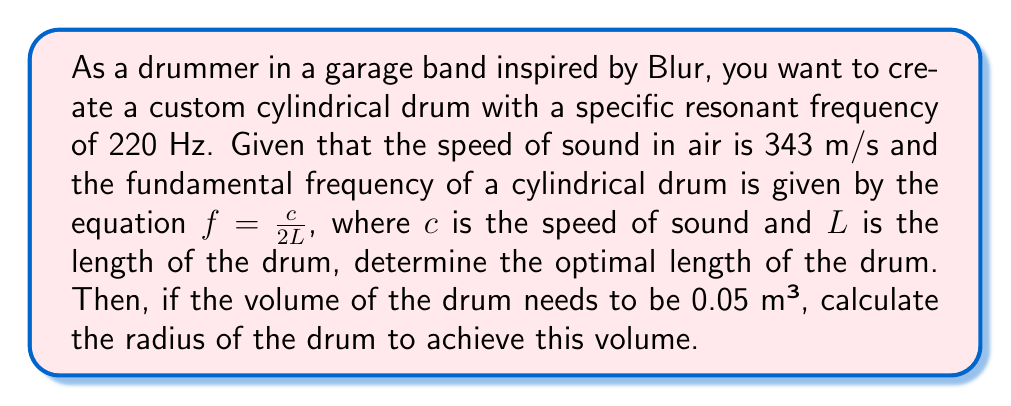Could you help me with this problem? 1. First, let's determine the length of the drum using the given equation:
   $f = \frac{c}{2L}$

   Rearranging the equation to solve for $L$:
   $L = \frac{c}{2f}$

2. Substituting the known values:
   $L = \frac{343 \text{ m/s}}{2(220 \text{ Hz})} = 0.7795 \text{ m}$

3. Now that we have the length, we can use the volume formula for a cylinder to find the radius:
   $V = \pi r^2 h$

   Where $V$ is the volume, $r$ is the radius, and $h$ is the height (length) of the cylinder.

4. Rearranging the equation to solve for $r$:
   $r = \sqrt{\frac{V}{\pi h}}$

5. Substituting the known values:
   $r = \sqrt{\frac{0.05 \text{ m}³}{\pi(0.7795 \text{ m})}}$

6. Simplifying:
   $r = \sqrt{\frac{0.05}{2.4483}} = 0.1429 \text{ m}$

Therefore, the optimal dimensions for the drum are:
Length (L) = 0.7795 m
Radius (r) = 0.1429 m
Answer: L = 0.7795 m, r = 0.1429 m 